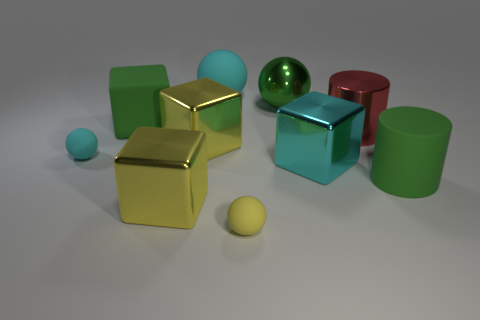Subtract all large green metallic balls. How many balls are left? 3 Subtract all yellow cubes. How many cubes are left? 2 Subtract 0 blue spheres. How many objects are left? 10 Subtract all cylinders. How many objects are left? 8 Subtract 1 blocks. How many blocks are left? 3 Subtract all cyan blocks. Subtract all brown cylinders. How many blocks are left? 3 Subtract all red cylinders. How many yellow cubes are left? 2 Subtract all small purple rubber cylinders. Subtract all large green matte cylinders. How many objects are left? 9 Add 5 green objects. How many green objects are left? 8 Add 2 yellow shiny cubes. How many yellow shiny cubes exist? 4 